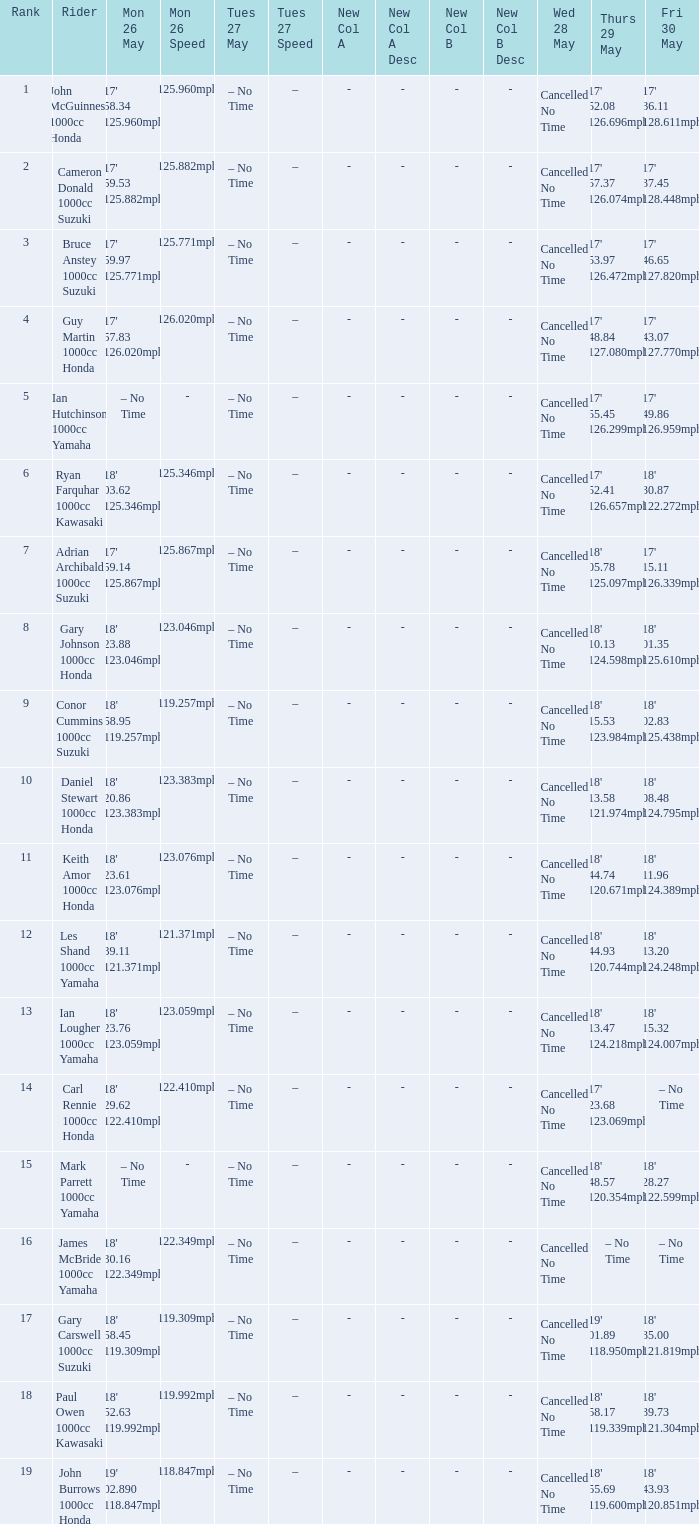What is the numbr for fri may 30 and mon may 26 is 19' 02.890 118.847mph? 18' 43.93 120.851mph. 